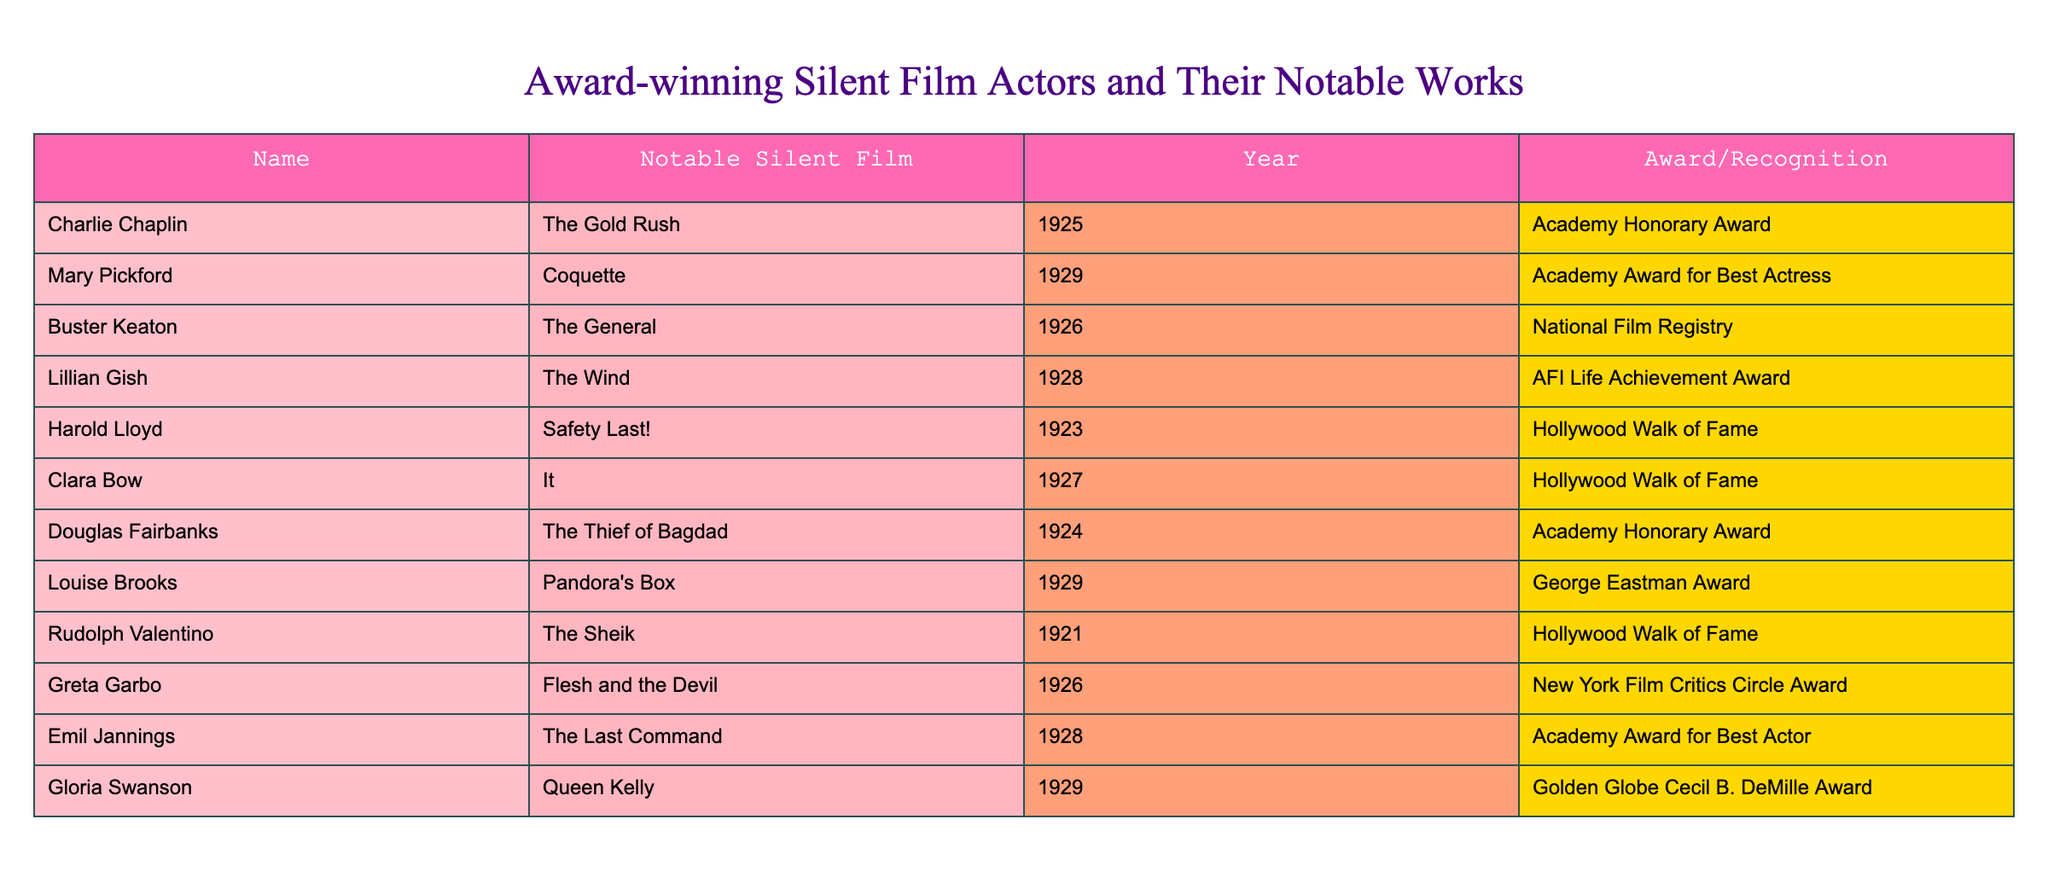What notable silent film did Charlie Chaplin star in? The table lists Charlie Chaplin with his notable silent film being "The Gold Rush."
Answer: The Gold Rush Which actor received the Academy Award for Best Actress? According to the table, Mary Pickford is the actor who received the Academy Award for Best Actress for her performance in "Coquette."
Answer: Mary Pickford How many actors listed are associated with the Hollywood Walk of Fame? From the table, Harold Lloyd, Clara Bow, and Rudolph Valentino are mentioned as associated with the Hollywood Walk of Fame, which counts to three actors.
Answer: 3 Did any actors win awards for films released in 1928? Looking at the table, both Lillian Gish and Emil Jannings received awards for films released in 1928 ("The Wind" and "The Last Command," respectively), confirming that the statement is true.
Answer: Yes Which actor has the earliest notable film listed, and what is it? The earliest notable film in the table is "Safety Last!" by Harold Lloyd, released in 1923. To confirm, I can check the years mentioned for each actor and note that 1923 is the earliest.
Answer: Harold Lloyd, Safety Last! What is the total number of silent films awarded in the 1920s based on this table? The table shows silent films awarded throughout the 1920s (totaling six: "The Gold Rush," "The General," "The Wind," "Safety Last!," "Flesh and the Devil," and "The Last Command"). Thus, I add them up, resulting in a total of six films.
Answer: 6 Who has an award named after a famous filmmaker? The table indicates that Gloria Swanson received the Golden Globe Cecil B. DeMille Award, named after director Cecil B. DeMille, establishing the answer to be true.
Answer: Yes Which actor's notable work was recognized by the National Film Registry? Buster Keaton's notable film "The General" is recognized by the National Film Registry as indicated in the table, making this statement accurate.
Answer: Buster Keaton, The General What percentage of the actors listed won an Academy Award? There are 13 actors in the table, and 3 of them won an Academy Award (Mary Pickford, Emil Jannings, Douglas Fairbanks). By dividing 3 by 13 and multiplying by 100 results in approximately 23.08%.
Answer: 23.08% 